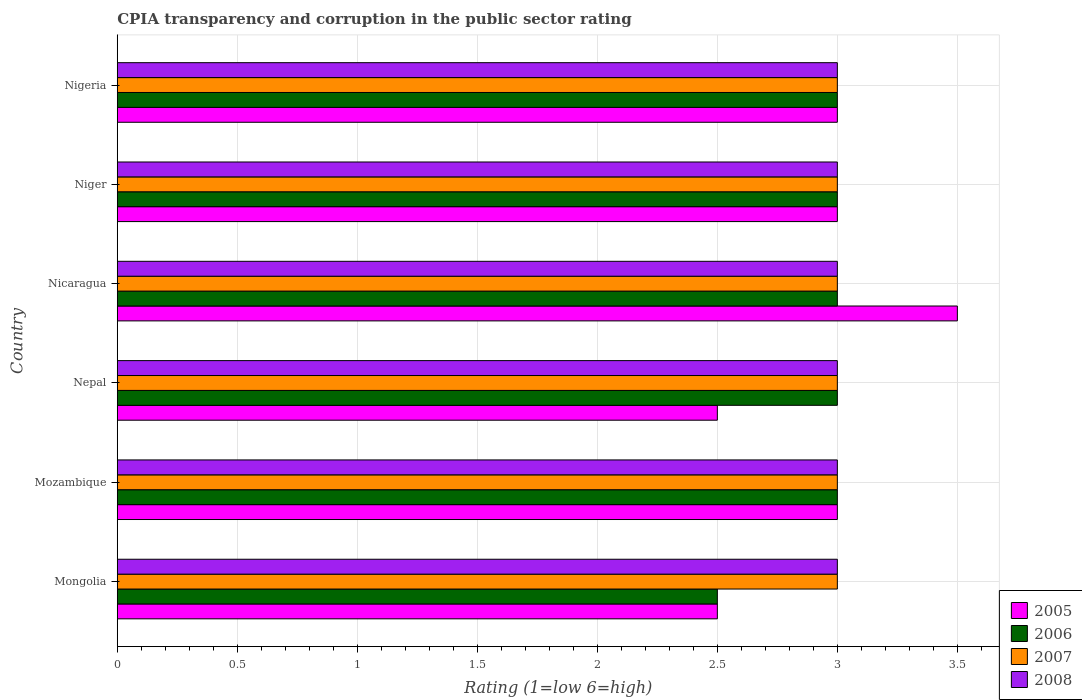How many different coloured bars are there?
Your response must be concise. 4. Are the number of bars per tick equal to the number of legend labels?
Your answer should be compact. Yes. How many bars are there on the 4th tick from the top?
Provide a short and direct response. 4. What is the label of the 4th group of bars from the top?
Give a very brief answer. Nepal. In how many cases, is the number of bars for a given country not equal to the number of legend labels?
Make the answer very short. 0. Across all countries, what is the maximum CPIA rating in 2007?
Offer a very short reply. 3. Across all countries, what is the minimum CPIA rating in 2006?
Your response must be concise. 2.5. In which country was the CPIA rating in 2007 maximum?
Your answer should be very brief. Mongolia. In which country was the CPIA rating in 2007 minimum?
Your answer should be very brief. Mongolia. What is the total CPIA rating in 2005 in the graph?
Your answer should be compact. 17.5. What is the average CPIA rating in 2005 per country?
Provide a succinct answer. 2.92. What is the ratio of the CPIA rating in 2006 in Nepal to that in Nigeria?
Make the answer very short. 1. Is the difference between the CPIA rating in 2008 in Mongolia and Mozambique greater than the difference between the CPIA rating in 2006 in Mongolia and Mozambique?
Make the answer very short. Yes. Is the sum of the CPIA rating in 2007 in Nepal and Niger greater than the maximum CPIA rating in 2008 across all countries?
Your answer should be very brief. Yes. What does the 1st bar from the bottom in Nigeria represents?
Make the answer very short. 2005. What is the difference between two consecutive major ticks on the X-axis?
Your answer should be compact. 0.5. Are the values on the major ticks of X-axis written in scientific E-notation?
Offer a very short reply. No. Does the graph contain grids?
Provide a succinct answer. Yes. Where does the legend appear in the graph?
Make the answer very short. Bottom right. How many legend labels are there?
Your response must be concise. 4. What is the title of the graph?
Give a very brief answer. CPIA transparency and corruption in the public sector rating. What is the label or title of the Y-axis?
Keep it short and to the point. Country. What is the Rating (1=low 6=high) of 2005 in Mongolia?
Your answer should be very brief. 2.5. What is the Rating (1=low 6=high) in 2005 in Nicaragua?
Your answer should be very brief. 3.5. What is the Rating (1=low 6=high) in 2006 in Nicaragua?
Your answer should be compact. 3. What is the Rating (1=low 6=high) in 2007 in Nicaragua?
Ensure brevity in your answer.  3. What is the Rating (1=low 6=high) of 2008 in Nicaragua?
Provide a succinct answer. 3. What is the Rating (1=low 6=high) of 2006 in Niger?
Your answer should be compact. 3. What is the Rating (1=low 6=high) of 2007 in Niger?
Your answer should be very brief. 3. What is the Rating (1=low 6=high) in 2008 in Niger?
Your response must be concise. 3. What is the Rating (1=low 6=high) in 2005 in Nigeria?
Offer a terse response. 3. What is the Rating (1=low 6=high) in 2007 in Nigeria?
Offer a terse response. 3. What is the Rating (1=low 6=high) of 2008 in Nigeria?
Ensure brevity in your answer.  3. Across all countries, what is the maximum Rating (1=low 6=high) in 2006?
Give a very brief answer. 3. Across all countries, what is the maximum Rating (1=low 6=high) of 2007?
Your answer should be very brief. 3. Across all countries, what is the maximum Rating (1=low 6=high) of 2008?
Provide a succinct answer. 3. Across all countries, what is the minimum Rating (1=low 6=high) in 2006?
Ensure brevity in your answer.  2.5. Across all countries, what is the minimum Rating (1=low 6=high) of 2007?
Make the answer very short. 3. What is the total Rating (1=low 6=high) of 2007 in the graph?
Your answer should be compact. 18. What is the total Rating (1=low 6=high) in 2008 in the graph?
Provide a succinct answer. 18. What is the difference between the Rating (1=low 6=high) of 2007 in Mongolia and that in Mozambique?
Provide a short and direct response. 0. What is the difference between the Rating (1=low 6=high) in 2008 in Mongolia and that in Mozambique?
Ensure brevity in your answer.  0. What is the difference between the Rating (1=low 6=high) of 2005 in Mongolia and that in Nepal?
Give a very brief answer. 0. What is the difference between the Rating (1=low 6=high) in 2006 in Mongolia and that in Nepal?
Ensure brevity in your answer.  -0.5. What is the difference between the Rating (1=low 6=high) of 2005 in Mongolia and that in Nicaragua?
Make the answer very short. -1. What is the difference between the Rating (1=low 6=high) in 2006 in Mongolia and that in Nicaragua?
Provide a succinct answer. -0.5. What is the difference between the Rating (1=low 6=high) in 2008 in Mongolia and that in Nicaragua?
Give a very brief answer. 0. What is the difference between the Rating (1=low 6=high) in 2005 in Mongolia and that in Niger?
Ensure brevity in your answer.  -0.5. What is the difference between the Rating (1=low 6=high) in 2006 in Mongolia and that in Niger?
Provide a succinct answer. -0.5. What is the difference between the Rating (1=low 6=high) in 2006 in Mongolia and that in Nigeria?
Provide a short and direct response. -0.5. What is the difference between the Rating (1=low 6=high) of 2005 in Mozambique and that in Nepal?
Make the answer very short. 0.5. What is the difference between the Rating (1=low 6=high) in 2007 in Mozambique and that in Nepal?
Give a very brief answer. 0. What is the difference between the Rating (1=low 6=high) in 2008 in Mozambique and that in Nepal?
Ensure brevity in your answer.  0. What is the difference between the Rating (1=low 6=high) in 2005 in Mozambique and that in Nicaragua?
Provide a short and direct response. -0.5. What is the difference between the Rating (1=low 6=high) of 2006 in Mozambique and that in Nicaragua?
Offer a terse response. 0. What is the difference between the Rating (1=low 6=high) of 2008 in Mozambique and that in Nicaragua?
Offer a terse response. 0. What is the difference between the Rating (1=low 6=high) in 2007 in Mozambique and that in Niger?
Your response must be concise. 0. What is the difference between the Rating (1=low 6=high) in 2008 in Mozambique and that in Niger?
Give a very brief answer. 0. What is the difference between the Rating (1=low 6=high) in 2005 in Mozambique and that in Nigeria?
Your answer should be compact. 0. What is the difference between the Rating (1=low 6=high) of 2006 in Mozambique and that in Nigeria?
Give a very brief answer. 0. What is the difference between the Rating (1=low 6=high) of 2006 in Nepal and that in Nicaragua?
Ensure brevity in your answer.  0. What is the difference between the Rating (1=low 6=high) in 2008 in Nepal and that in Nicaragua?
Provide a short and direct response. 0. What is the difference between the Rating (1=low 6=high) of 2005 in Nepal and that in Niger?
Your answer should be compact. -0.5. What is the difference between the Rating (1=low 6=high) of 2007 in Nepal and that in Niger?
Keep it short and to the point. 0. What is the difference between the Rating (1=low 6=high) of 2006 in Nepal and that in Nigeria?
Provide a succinct answer. 0. What is the difference between the Rating (1=low 6=high) of 2007 in Nepal and that in Nigeria?
Your answer should be very brief. 0. What is the difference between the Rating (1=low 6=high) of 2008 in Nepal and that in Nigeria?
Give a very brief answer. 0. What is the difference between the Rating (1=low 6=high) of 2008 in Nicaragua and that in Niger?
Your answer should be very brief. 0. What is the difference between the Rating (1=low 6=high) of 2005 in Nicaragua and that in Nigeria?
Give a very brief answer. 0.5. What is the difference between the Rating (1=low 6=high) in 2007 in Nicaragua and that in Nigeria?
Your response must be concise. 0. What is the difference between the Rating (1=low 6=high) in 2008 in Nicaragua and that in Nigeria?
Your response must be concise. 0. What is the difference between the Rating (1=low 6=high) of 2005 in Niger and that in Nigeria?
Your response must be concise. 0. What is the difference between the Rating (1=low 6=high) of 2008 in Niger and that in Nigeria?
Make the answer very short. 0. What is the difference between the Rating (1=low 6=high) in 2005 in Mongolia and the Rating (1=low 6=high) in 2006 in Mozambique?
Provide a short and direct response. -0.5. What is the difference between the Rating (1=low 6=high) of 2007 in Mongolia and the Rating (1=low 6=high) of 2008 in Mozambique?
Provide a succinct answer. 0. What is the difference between the Rating (1=low 6=high) of 2005 in Mongolia and the Rating (1=low 6=high) of 2006 in Nepal?
Ensure brevity in your answer.  -0.5. What is the difference between the Rating (1=low 6=high) of 2006 in Mongolia and the Rating (1=low 6=high) of 2007 in Nepal?
Offer a very short reply. -0.5. What is the difference between the Rating (1=low 6=high) in 2006 in Mongolia and the Rating (1=low 6=high) in 2008 in Nepal?
Offer a very short reply. -0.5. What is the difference between the Rating (1=low 6=high) in 2007 in Mongolia and the Rating (1=low 6=high) in 2008 in Nepal?
Give a very brief answer. 0. What is the difference between the Rating (1=low 6=high) in 2005 in Mongolia and the Rating (1=low 6=high) in 2007 in Nicaragua?
Give a very brief answer. -0.5. What is the difference between the Rating (1=low 6=high) in 2006 in Mongolia and the Rating (1=low 6=high) in 2007 in Nicaragua?
Your response must be concise. -0.5. What is the difference between the Rating (1=low 6=high) in 2007 in Mongolia and the Rating (1=low 6=high) in 2008 in Nicaragua?
Offer a terse response. 0. What is the difference between the Rating (1=low 6=high) of 2005 in Mongolia and the Rating (1=low 6=high) of 2008 in Niger?
Ensure brevity in your answer.  -0.5. What is the difference between the Rating (1=low 6=high) in 2006 in Mongolia and the Rating (1=low 6=high) in 2007 in Niger?
Offer a terse response. -0.5. What is the difference between the Rating (1=low 6=high) of 2006 in Mongolia and the Rating (1=low 6=high) of 2008 in Niger?
Your answer should be very brief. -0.5. What is the difference between the Rating (1=low 6=high) in 2007 in Mongolia and the Rating (1=low 6=high) in 2008 in Niger?
Your answer should be very brief. 0. What is the difference between the Rating (1=low 6=high) of 2005 in Mongolia and the Rating (1=low 6=high) of 2006 in Nigeria?
Offer a terse response. -0.5. What is the difference between the Rating (1=low 6=high) in 2005 in Mongolia and the Rating (1=low 6=high) in 2008 in Nigeria?
Provide a succinct answer. -0.5. What is the difference between the Rating (1=low 6=high) of 2006 in Mongolia and the Rating (1=low 6=high) of 2008 in Nigeria?
Your response must be concise. -0.5. What is the difference between the Rating (1=low 6=high) of 2005 in Mozambique and the Rating (1=low 6=high) of 2006 in Nepal?
Provide a short and direct response. 0. What is the difference between the Rating (1=low 6=high) of 2005 in Mozambique and the Rating (1=low 6=high) of 2007 in Nepal?
Ensure brevity in your answer.  0. What is the difference between the Rating (1=low 6=high) in 2006 in Mozambique and the Rating (1=low 6=high) in 2007 in Nepal?
Offer a terse response. 0. What is the difference between the Rating (1=low 6=high) in 2006 in Mozambique and the Rating (1=low 6=high) in 2008 in Nepal?
Your answer should be compact. 0. What is the difference between the Rating (1=low 6=high) in 2007 in Mozambique and the Rating (1=low 6=high) in 2008 in Nepal?
Provide a succinct answer. 0. What is the difference between the Rating (1=low 6=high) in 2005 in Mozambique and the Rating (1=low 6=high) in 2007 in Nicaragua?
Make the answer very short. 0. What is the difference between the Rating (1=low 6=high) in 2006 in Mozambique and the Rating (1=low 6=high) in 2007 in Nicaragua?
Your answer should be very brief. 0. What is the difference between the Rating (1=low 6=high) in 2007 in Mozambique and the Rating (1=low 6=high) in 2008 in Nicaragua?
Keep it short and to the point. 0. What is the difference between the Rating (1=low 6=high) of 2006 in Mozambique and the Rating (1=low 6=high) of 2008 in Niger?
Provide a short and direct response. 0. What is the difference between the Rating (1=low 6=high) in 2005 in Mozambique and the Rating (1=low 6=high) in 2007 in Nigeria?
Keep it short and to the point. 0. What is the difference between the Rating (1=low 6=high) of 2006 in Mozambique and the Rating (1=low 6=high) of 2007 in Nigeria?
Make the answer very short. 0. What is the difference between the Rating (1=low 6=high) of 2007 in Mozambique and the Rating (1=low 6=high) of 2008 in Nigeria?
Make the answer very short. 0. What is the difference between the Rating (1=low 6=high) of 2005 in Nepal and the Rating (1=low 6=high) of 2006 in Nicaragua?
Provide a short and direct response. -0.5. What is the difference between the Rating (1=low 6=high) of 2005 in Nepal and the Rating (1=low 6=high) of 2007 in Nicaragua?
Your answer should be compact. -0.5. What is the difference between the Rating (1=low 6=high) of 2006 in Nepal and the Rating (1=low 6=high) of 2007 in Nicaragua?
Your answer should be very brief. 0. What is the difference between the Rating (1=low 6=high) of 2007 in Nepal and the Rating (1=low 6=high) of 2008 in Nicaragua?
Make the answer very short. 0. What is the difference between the Rating (1=low 6=high) in 2005 in Nepal and the Rating (1=low 6=high) in 2006 in Niger?
Make the answer very short. -0.5. What is the difference between the Rating (1=low 6=high) in 2005 in Nepal and the Rating (1=low 6=high) in 2008 in Niger?
Provide a short and direct response. -0.5. What is the difference between the Rating (1=low 6=high) in 2007 in Nepal and the Rating (1=low 6=high) in 2008 in Niger?
Your response must be concise. 0. What is the difference between the Rating (1=low 6=high) in 2005 in Nepal and the Rating (1=low 6=high) in 2007 in Nigeria?
Your answer should be compact. -0.5. What is the difference between the Rating (1=low 6=high) in 2006 in Nepal and the Rating (1=low 6=high) in 2007 in Nigeria?
Provide a short and direct response. 0. What is the difference between the Rating (1=low 6=high) of 2006 in Nepal and the Rating (1=low 6=high) of 2008 in Nigeria?
Your answer should be very brief. 0. What is the difference between the Rating (1=low 6=high) in 2005 in Nicaragua and the Rating (1=low 6=high) in 2006 in Niger?
Offer a terse response. 0.5. What is the difference between the Rating (1=low 6=high) of 2005 in Nicaragua and the Rating (1=low 6=high) of 2007 in Niger?
Your answer should be compact. 0.5. What is the difference between the Rating (1=low 6=high) in 2006 in Nicaragua and the Rating (1=low 6=high) in 2007 in Niger?
Ensure brevity in your answer.  0. What is the difference between the Rating (1=low 6=high) of 2006 in Nicaragua and the Rating (1=low 6=high) of 2008 in Niger?
Your answer should be very brief. 0. What is the difference between the Rating (1=low 6=high) of 2005 in Nicaragua and the Rating (1=low 6=high) of 2006 in Nigeria?
Keep it short and to the point. 0.5. What is the difference between the Rating (1=low 6=high) of 2005 in Nicaragua and the Rating (1=low 6=high) of 2007 in Nigeria?
Offer a very short reply. 0.5. What is the difference between the Rating (1=low 6=high) of 2005 in Nicaragua and the Rating (1=low 6=high) of 2008 in Nigeria?
Your answer should be compact. 0.5. What is the difference between the Rating (1=low 6=high) in 2006 in Nicaragua and the Rating (1=low 6=high) in 2007 in Nigeria?
Offer a very short reply. 0. What is the difference between the Rating (1=low 6=high) of 2006 in Nicaragua and the Rating (1=low 6=high) of 2008 in Nigeria?
Ensure brevity in your answer.  0. What is the difference between the Rating (1=low 6=high) in 2007 in Nicaragua and the Rating (1=low 6=high) in 2008 in Nigeria?
Provide a succinct answer. 0. What is the difference between the Rating (1=low 6=high) of 2005 in Niger and the Rating (1=low 6=high) of 2006 in Nigeria?
Give a very brief answer. 0. What is the difference between the Rating (1=low 6=high) in 2005 in Niger and the Rating (1=low 6=high) in 2007 in Nigeria?
Your response must be concise. 0. What is the difference between the Rating (1=low 6=high) of 2005 in Niger and the Rating (1=low 6=high) of 2008 in Nigeria?
Your response must be concise. 0. What is the difference between the Rating (1=low 6=high) in 2006 in Niger and the Rating (1=low 6=high) in 2007 in Nigeria?
Your answer should be very brief. 0. What is the difference between the Rating (1=low 6=high) of 2006 in Niger and the Rating (1=low 6=high) of 2008 in Nigeria?
Give a very brief answer. 0. What is the average Rating (1=low 6=high) of 2005 per country?
Offer a terse response. 2.92. What is the average Rating (1=low 6=high) in 2006 per country?
Your response must be concise. 2.92. What is the average Rating (1=low 6=high) of 2008 per country?
Provide a short and direct response. 3. What is the difference between the Rating (1=low 6=high) of 2005 and Rating (1=low 6=high) of 2006 in Mongolia?
Provide a short and direct response. 0. What is the difference between the Rating (1=low 6=high) of 2005 and Rating (1=low 6=high) of 2007 in Mongolia?
Keep it short and to the point. -0.5. What is the difference between the Rating (1=low 6=high) of 2006 and Rating (1=low 6=high) of 2008 in Mongolia?
Your response must be concise. -0.5. What is the difference between the Rating (1=low 6=high) of 2007 and Rating (1=low 6=high) of 2008 in Mongolia?
Offer a terse response. 0. What is the difference between the Rating (1=low 6=high) in 2005 and Rating (1=low 6=high) in 2006 in Mozambique?
Provide a succinct answer. 0. What is the difference between the Rating (1=low 6=high) of 2005 and Rating (1=low 6=high) of 2007 in Mozambique?
Offer a very short reply. 0. What is the difference between the Rating (1=low 6=high) in 2005 and Rating (1=low 6=high) in 2008 in Mozambique?
Offer a terse response. 0. What is the difference between the Rating (1=low 6=high) in 2006 and Rating (1=low 6=high) in 2007 in Mozambique?
Your response must be concise. 0. What is the difference between the Rating (1=low 6=high) of 2007 and Rating (1=low 6=high) of 2008 in Mozambique?
Ensure brevity in your answer.  0. What is the difference between the Rating (1=low 6=high) of 2005 and Rating (1=low 6=high) of 2006 in Nepal?
Offer a terse response. -0.5. What is the difference between the Rating (1=low 6=high) in 2005 and Rating (1=low 6=high) in 2006 in Nicaragua?
Offer a very short reply. 0.5. What is the difference between the Rating (1=low 6=high) of 2006 and Rating (1=low 6=high) of 2007 in Nicaragua?
Ensure brevity in your answer.  0. What is the difference between the Rating (1=low 6=high) in 2007 and Rating (1=low 6=high) in 2008 in Nicaragua?
Your answer should be very brief. 0. What is the difference between the Rating (1=low 6=high) of 2005 and Rating (1=low 6=high) of 2006 in Niger?
Provide a succinct answer. 0. What is the difference between the Rating (1=low 6=high) of 2005 and Rating (1=low 6=high) of 2007 in Niger?
Give a very brief answer. 0. What is the difference between the Rating (1=low 6=high) of 2005 and Rating (1=low 6=high) of 2008 in Niger?
Offer a very short reply. 0. What is the difference between the Rating (1=low 6=high) in 2006 and Rating (1=low 6=high) in 2008 in Niger?
Give a very brief answer. 0. What is the difference between the Rating (1=low 6=high) in 2007 and Rating (1=low 6=high) in 2008 in Niger?
Keep it short and to the point. 0. What is the difference between the Rating (1=low 6=high) in 2005 and Rating (1=low 6=high) in 2007 in Nigeria?
Provide a short and direct response. 0. What is the difference between the Rating (1=low 6=high) of 2005 and Rating (1=low 6=high) of 2008 in Nigeria?
Offer a very short reply. 0. What is the difference between the Rating (1=low 6=high) in 2006 and Rating (1=low 6=high) in 2008 in Nigeria?
Give a very brief answer. 0. What is the difference between the Rating (1=low 6=high) in 2007 and Rating (1=low 6=high) in 2008 in Nigeria?
Give a very brief answer. 0. What is the ratio of the Rating (1=low 6=high) in 2005 in Mongolia to that in Mozambique?
Ensure brevity in your answer.  0.83. What is the ratio of the Rating (1=low 6=high) in 2006 in Mongolia to that in Nepal?
Your response must be concise. 0.83. What is the ratio of the Rating (1=low 6=high) of 2006 in Mongolia to that in Nicaragua?
Offer a very short reply. 0.83. What is the ratio of the Rating (1=low 6=high) of 2007 in Mongolia to that in Nicaragua?
Your answer should be very brief. 1. What is the ratio of the Rating (1=low 6=high) in 2008 in Mongolia to that in Nicaragua?
Ensure brevity in your answer.  1. What is the ratio of the Rating (1=low 6=high) of 2005 in Mongolia to that in Niger?
Offer a terse response. 0.83. What is the ratio of the Rating (1=low 6=high) of 2008 in Mongolia to that in Niger?
Offer a terse response. 1. What is the ratio of the Rating (1=low 6=high) of 2005 in Mongolia to that in Nigeria?
Your response must be concise. 0.83. What is the ratio of the Rating (1=low 6=high) in 2007 in Mongolia to that in Nigeria?
Ensure brevity in your answer.  1. What is the ratio of the Rating (1=low 6=high) of 2007 in Mozambique to that in Nepal?
Make the answer very short. 1. What is the ratio of the Rating (1=low 6=high) of 2008 in Mozambique to that in Nepal?
Make the answer very short. 1. What is the ratio of the Rating (1=low 6=high) in 2005 in Mozambique to that in Nicaragua?
Provide a succinct answer. 0.86. What is the ratio of the Rating (1=low 6=high) of 2006 in Mozambique to that in Nicaragua?
Offer a terse response. 1. What is the ratio of the Rating (1=low 6=high) in 2005 in Mozambique to that in Niger?
Provide a short and direct response. 1. What is the ratio of the Rating (1=low 6=high) in 2006 in Mozambique to that in Niger?
Offer a very short reply. 1. What is the ratio of the Rating (1=low 6=high) of 2008 in Mozambique to that in Nigeria?
Give a very brief answer. 1. What is the ratio of the Rating (1=low 6=high) of 2006 in Nepal to that in Nicaragua?
Keep it short and to the point. 1. What is the ratio of the Rating (1=low 6=high) of 2007 in Nepal to that in Nicaragua?
Your response must be concise. 1. What is the ratio of the Rating (1=low 6=high) in 2008 in Nepal to that in Nicaragua?
Offer a very short reply. 1. What is the ratio of the Rating (1=low 6=high) of 2005 in Nepal to that in Niger?
Keep it short and to the point. 0.83. What is the ratio of the Rating (1=low 6=high) of 2006 in Nepal to that in Niger?
Give a very brief answer. 1. What is the ratio of the Rating (1=low 6=high) in 2008 in Nepal to that in Niger?
Keep it short and to the point. 1. What is the ratio of the Rating (1=low 6=high) of 2006 in Nepal to that in Nigeria?
Offer a very short reply. 1. What is the ratio of the Rating (1=low 6=high) of 2007 in Nepal to that in Nigeria?
Make the answer very short. 1. What is the ratio of the Rating (1=low 6=high) in 2005 in Nicaragua to that in Niger?
Your answer should be very brief. 1.17. What is the ratio of the Rating (1=low 6=high) of 2007 in Nicaragua to that in Niger?
Offer a terse response. 1. What is the ratio of the Rating (1=low 6=high) of 2008 in Nicaragua to that in Niger?
Provide a short and direct response. 1. What is the ratio of the Rating (1=low 6=high) in 2008 in Nicaragua to that in Nigeria?
Your answer should be very brief. 1. What is the ratio of the Rating (1=low 6=high) in 2007 in Niger to that in Nigeria?
Your answer should be very brief. 1. What is the difference between the highest and the second highest Rating (1=low 6=high) in 2008?
Provide a succinct answer. 0. What is the difference between the highest and the lowest Rating (1=low 6=high) of 2005?
Your answer should be very brief. 1. What is the difference between the highest and the lowest Rating (1=low 6=high) of 2006?
Your response must be concise. 0.5. What is the difference between the highest and the lowest Rating (1=low 6=high) of 2008?
Provide a succinct answer. 0. 